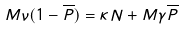<formula> <loc_0><loc_0><loc_500><loc_500>M \nu ( 1 - \overline { P } ) = \kappa N + M \gamma \overline { P }</formula> 